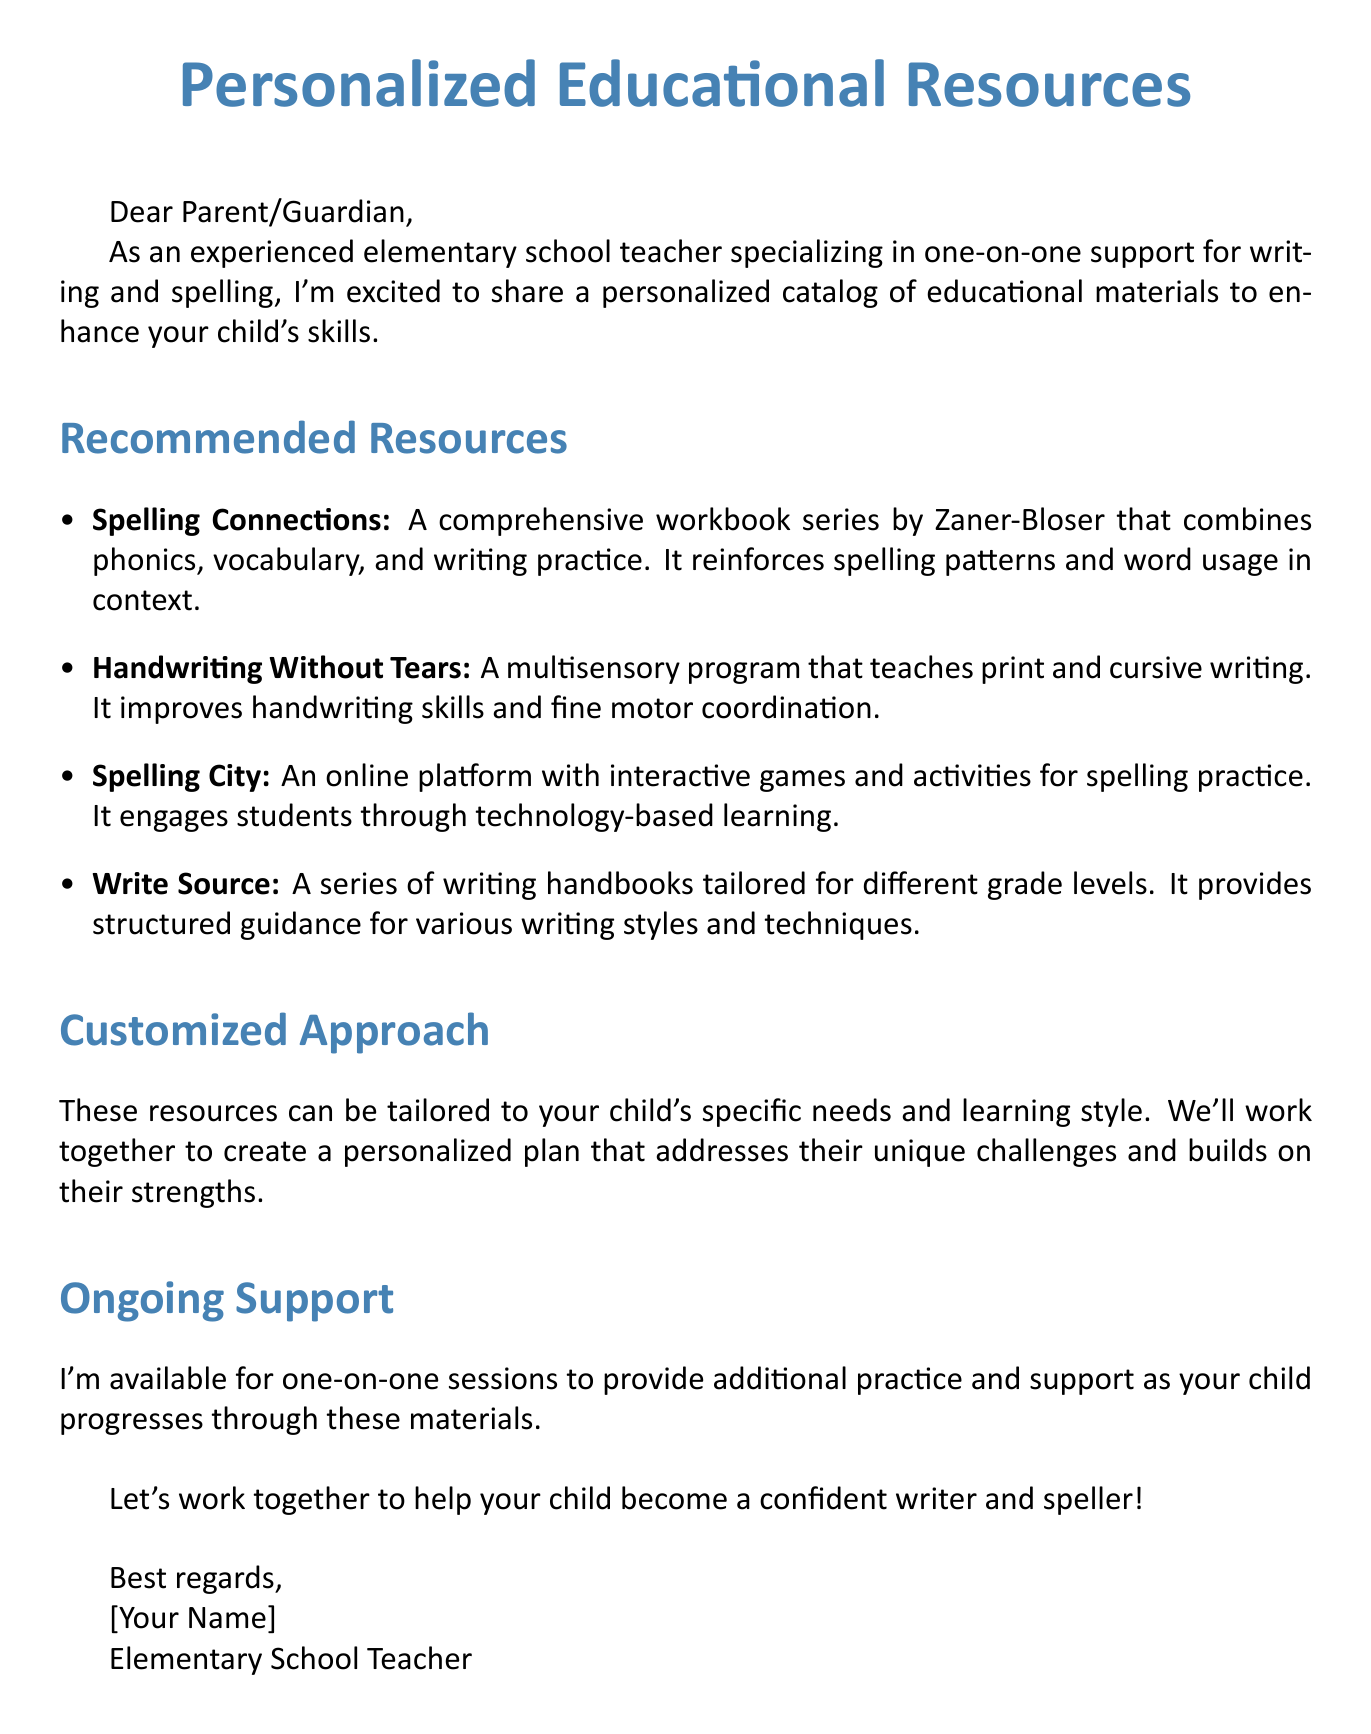What is the name of the first recommended resource? The first recommended resource listed in the document is "Spelling Connections."
Answer: Spelling Connections What type of program is "Handwriting Without Tears"? The document describes "Handwriting Without Tears" as a multisensory program.
Answer: multisensory program How many resources are listed in the document? The document contains a total of four recommended resources.
Answer: four What does "Spelling City" offer? According to the document, "Spelling City" offers an online platform with interactive games and activities for spelling practice.
Answer: online platform with interactive games Who is available for one-on-one sessions? The document states that the author, an elementary school teacher, is available for one-on-one sessions.
Answer: [Your Name] (the author) What is the main goal of the personalized catalog? The main goal of the personalized catalog is to enhance the child's writing and spelling skills.
Answer: enhance writing and spelling skills 